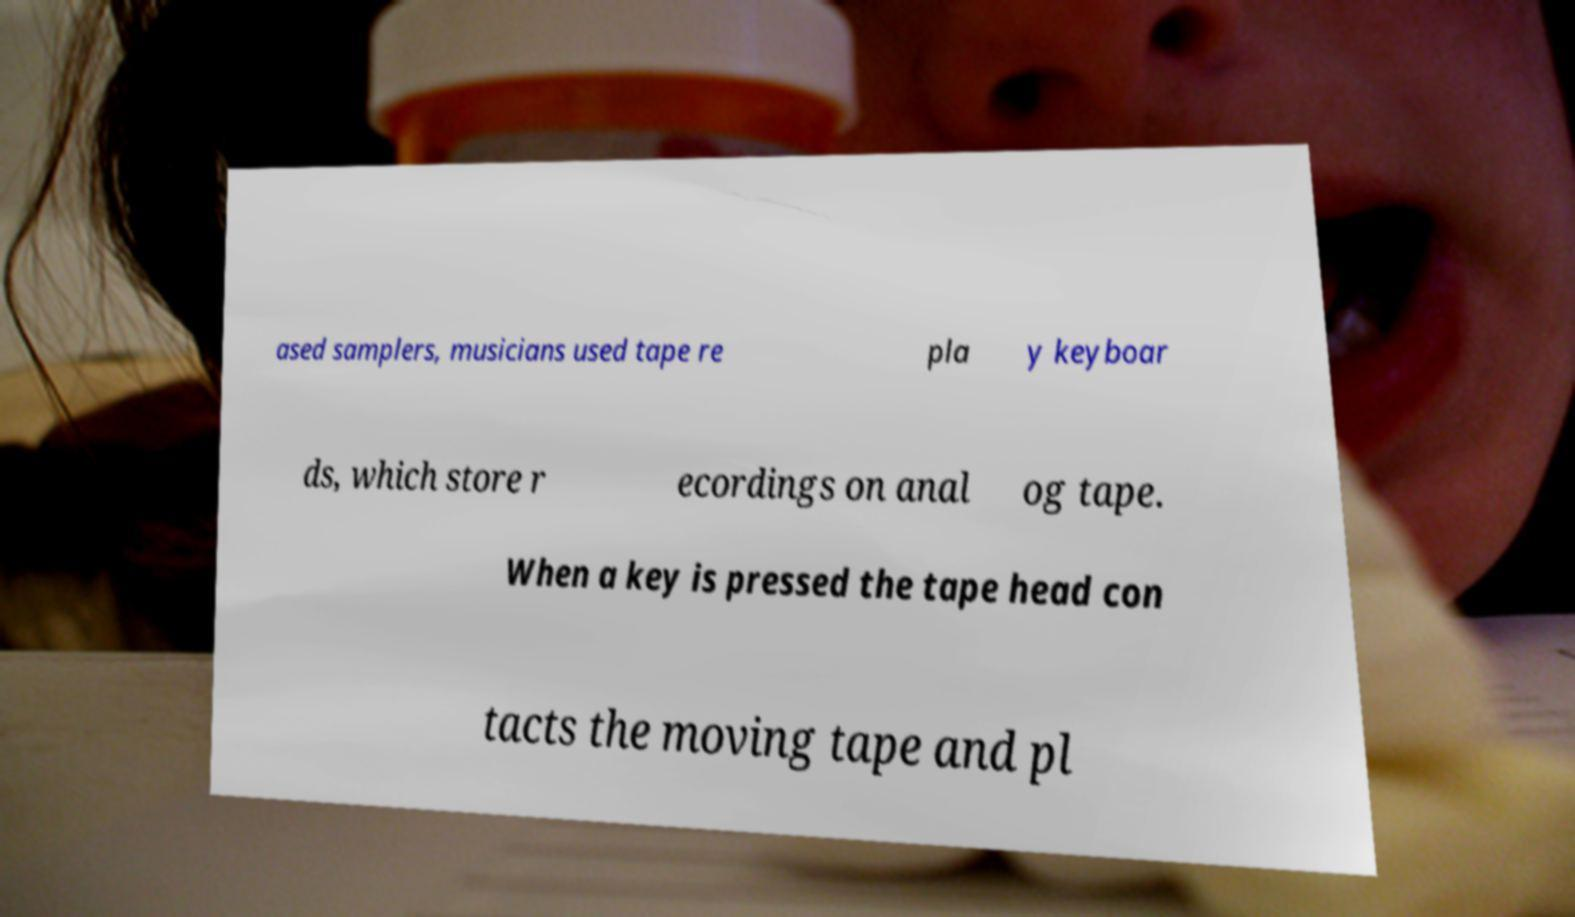Can you read and provide the text displayed in the image?This photo seems to have some interesting text. Can you extract and type it out for me? ased samplers, musicians used tape re pla y keyboar ds, which store r ecordings on anal og tape. When a key is pressed the tape head con tacts the moving tape and pl 